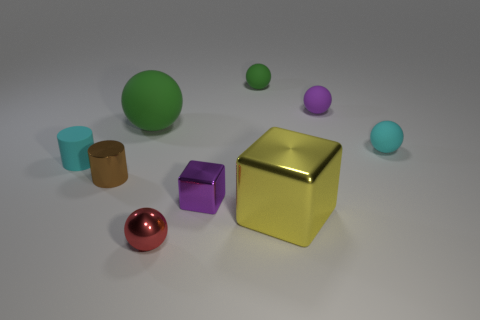How many green spheres must be subtracted to get 1 green spheres? 1 Subtract all purple rubber spheres. How many spheres are left? 4 Subtract 1 cubes. How many cubes are left? 1 Subtract all cyan cylinders. How many cylinders are left? 1 Subtract all gray cylinders. Subtract all yellow blocks. How many cylinders are left? 2 Add 1 small cyan rubber balls. How many small cyan rubber balls exist? 2 Subtract 0 gray balls. How many objects are left? 9 Subtract all spheres. How many objects are left? 4 Subtract all yellow blocks. How many red spheres are left? 1 Subtract all tiny yellow things. Subtract all matte cylinders. How many objects are left? 8 